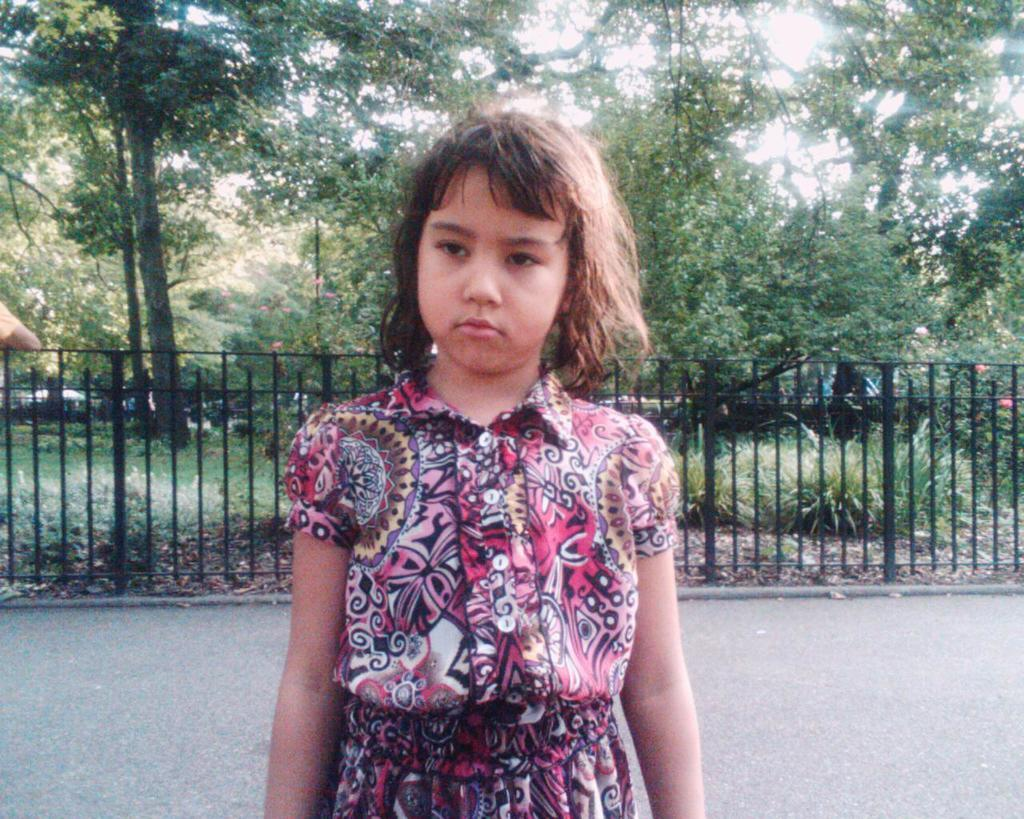What is the main subject of the image? There is a girl standing in the image. What can be seen in the background of the image? There is metal fencing and trees in the image. Are there any plants visible in the image? Yes, there are plants in the image. What type of books can be seen in the library in the image? There is no library present in the image, so it's not possible to determine what books might be seen. 